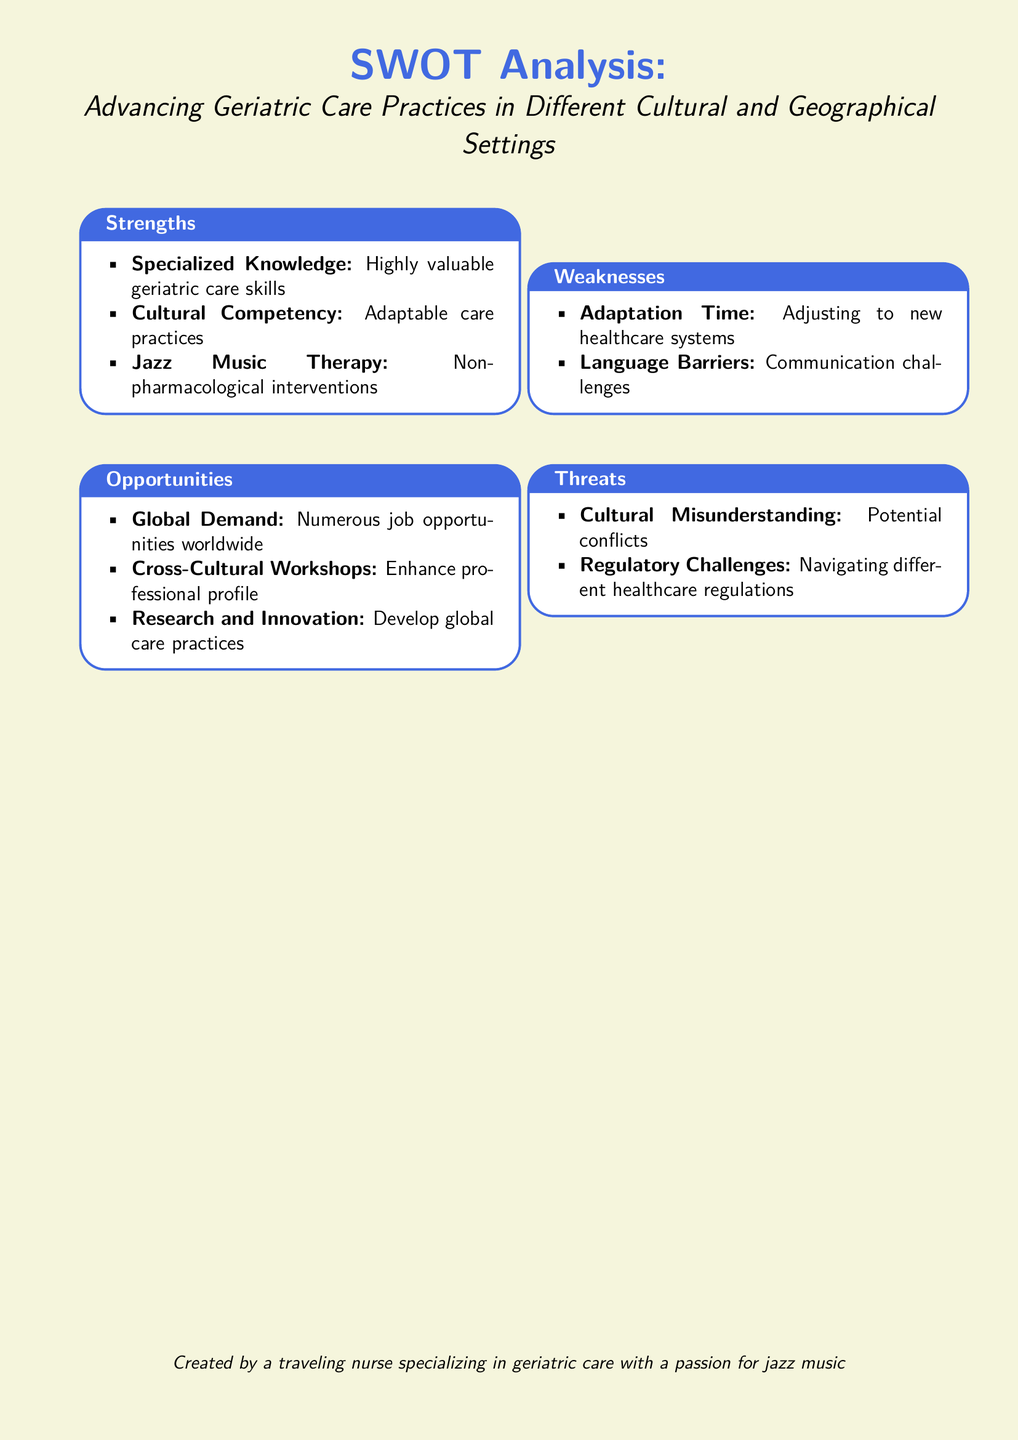What are the strengths listed in the SWOT analysis? The strengths listed under the SWOT analysis are 'Specialized Knowledge', 'Cultural Competency', and 'Jazz Music Therapy'.
Answer: Specialized Knowledge, Cultural Competency, Jazz Music Therapy What global demand is highlighted? The document points out 'Numerous job opportunities worldwide' as a global demand in geriatric care.
Answer: Numerous job opportunities worldwide What weakness is associated with language? The document identifies 'Language Barriers' as a weakness in advancing geriatric care practices.
Answer: Language Barriers What is one noted threat in the analysis? 'Cultural Misunderstanding' is mentioned as a potential threat when advancing geriatric care.
Answer: Cultural Misunderstanding How many distinct sections are there in the SWOT analysis? The document consists of four distinct sections: Strengths, Weaknesses, Opportunities, and Threats.
Answer: Four What kind of therapy is mentioned in the strengths? The SWOT analysis mentions 'Jazz Music Therapy' as a type of non-pharmacological intervention.
Answer: Jazz Music Therapy What opportunity is related to professional development? The document states that 'Cross-Cultural Workshops' will help enhance professional profiles.
Answer: Cross-Cultural Workshops What is one possible outcome of research and innovation as per the document? The document suggests that research and innovation may 'Develop global care practices'.
Answer: Develop global care practices What is the primary focus of the document? The primary focus of the document is on 'Advancing Geriatric Care Practices in Different Cultural and Geographical Settings'.
Answer: Advancing Geriatric Care Practices in Different Cultural and Geographical Settings 